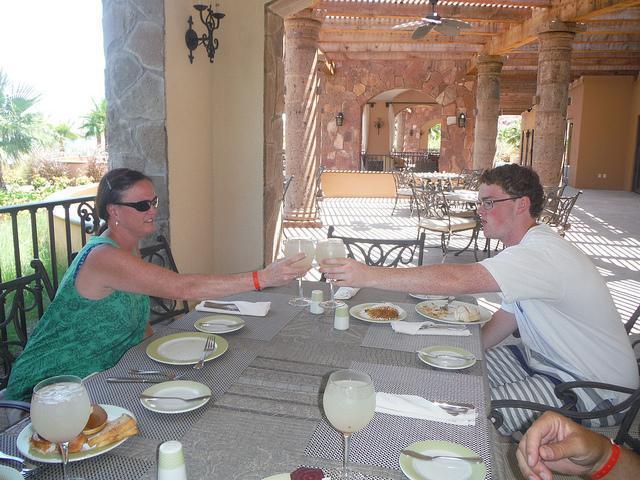How many wine glasses are there?
Give a very brief answer. 2. How many people are visible?
Give a very brief answer. 3. How many chairs can be seen?
Give a very brief answer. 3. How many surfboards are shown in this picture?
Give a very brief answer. 0. 